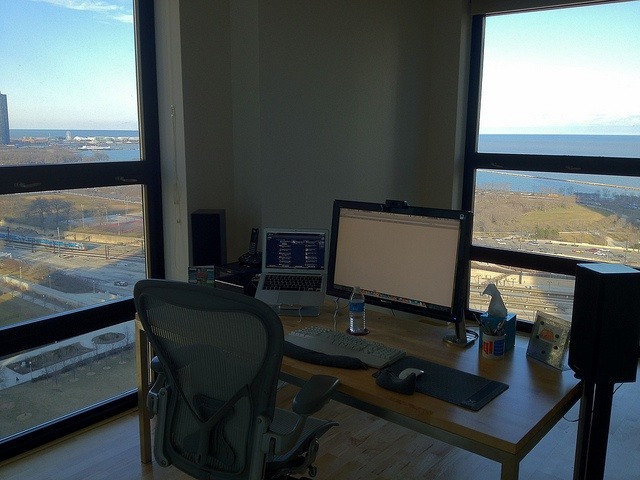Describe the objects in this image and their specific colors. I can see chair in lightblue, black, gray, and blue tones, tv in lightblue, gray, and black tones, laptop in lightblue, black, purple, and gray tones, keyboard in lightblue, black, and purple tones, and keyboard in black and lightblue tones in this image. 